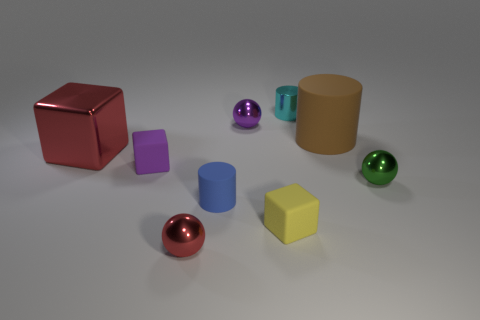What is the small block behind the tiny sphere that is right of the large matte thing made of?
Give a very brief answer. Rubber. What size is the block that is made of the same material as the tiny green thing?
Keep it short and to the point. Large. What is the size of the rubber thing right of the cyan object?
Keep it short and to the point. Large. There is a small object that is the same color as the big metallic cube; what shape is it?
Your response must be concise. Sphere. Is the material of the tiny green thing the same as the small block that is on the left side of the tiny blue thing?
Make the answer very short. No. The tiny purple object left of the cylinder on the left side of the cyan cylinder that is behind the blue object is made of what material?
Your answer should be compact. Rubber. How many other objects are the same size as the cyan object?
Your answer should be compact. 6. Does the purple object that is on the left side of the tiny red object have the same shape as the big brown thing?
Your answer should be very brief. No. The big shiny object that is the same shape as the yellow rubber object is what color?
Provide a succinct answer. Red. Are there any other things that are the same shape as the tiny green metallic thing?
Offer a very short reply. Yes. 